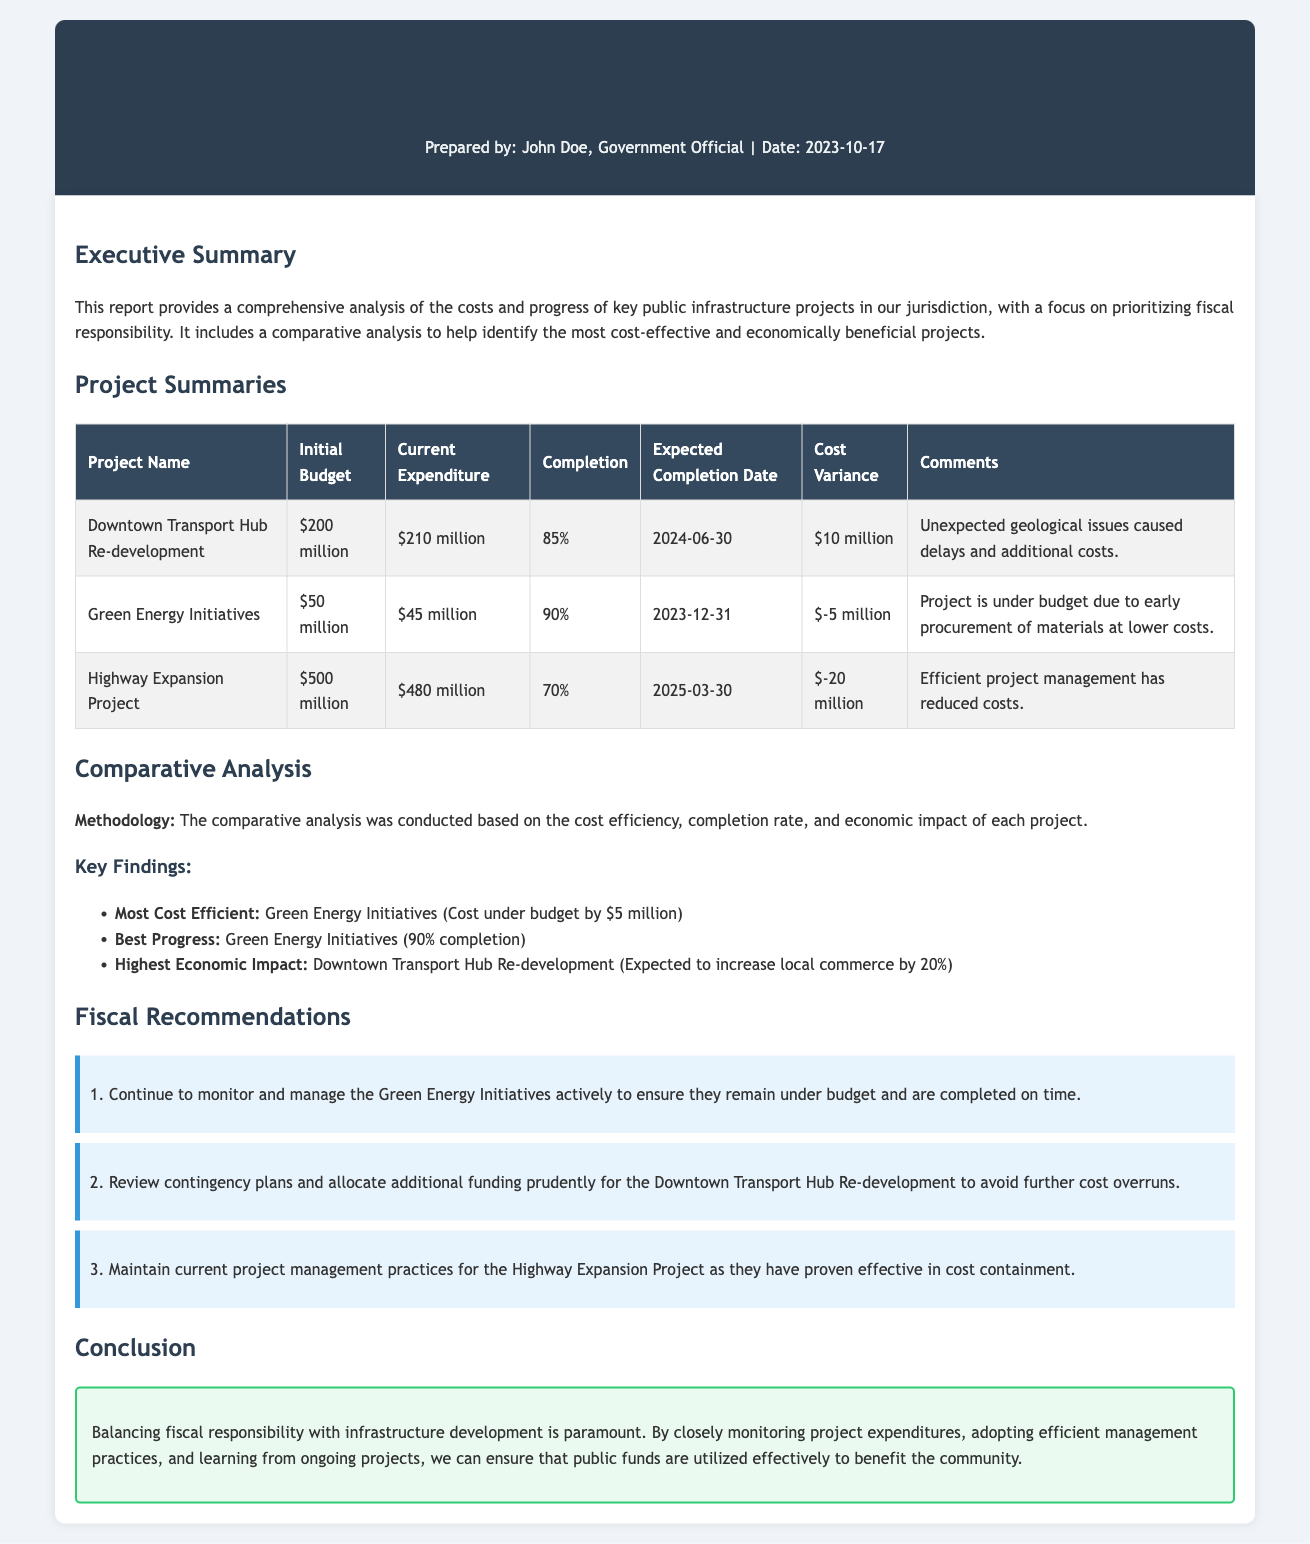What is the initial budget for the Downtown Transport Hub Re-development? The initial budget is specified in the project summaries table.
Answer: $200 million What percentage of completion is the Highway Expansion Project? The completion percentage can be found in the table under the 'Completion' column for the Highway Expansion Project.
Answer: 70% What is the expected completion date for the Green Energy Initiatives? The expected completion date is listed in the project summary table.
Answer: 2023-12-31 Which project is under budget and by how much? The document provides information about the costs and variances in the project summaries table.
Answer: Green Energy Initiatives, $5 million What is the highest economic impact project according to the report? The report includes comparative analysis results that indicate which project has the highest economic impact.
Answer: Downtown Transport Hub Re-development How many recommendations are provided in the report? The recommendations section includes a summarized list of suggestions made in the report.
Answer: 3 What is the total current expenditure for all projects combined? The total current expenditure is the sum of current expenditures listed for each project in the document.
Answer: $735 million What comment was made regarding the Downtown Transport Hub Re-development? The comments about the projects can be found in the project summaries table under the 'Comments' column for the Downtown project.
Answer: Unexpected geological issues caused delays and additional costs 